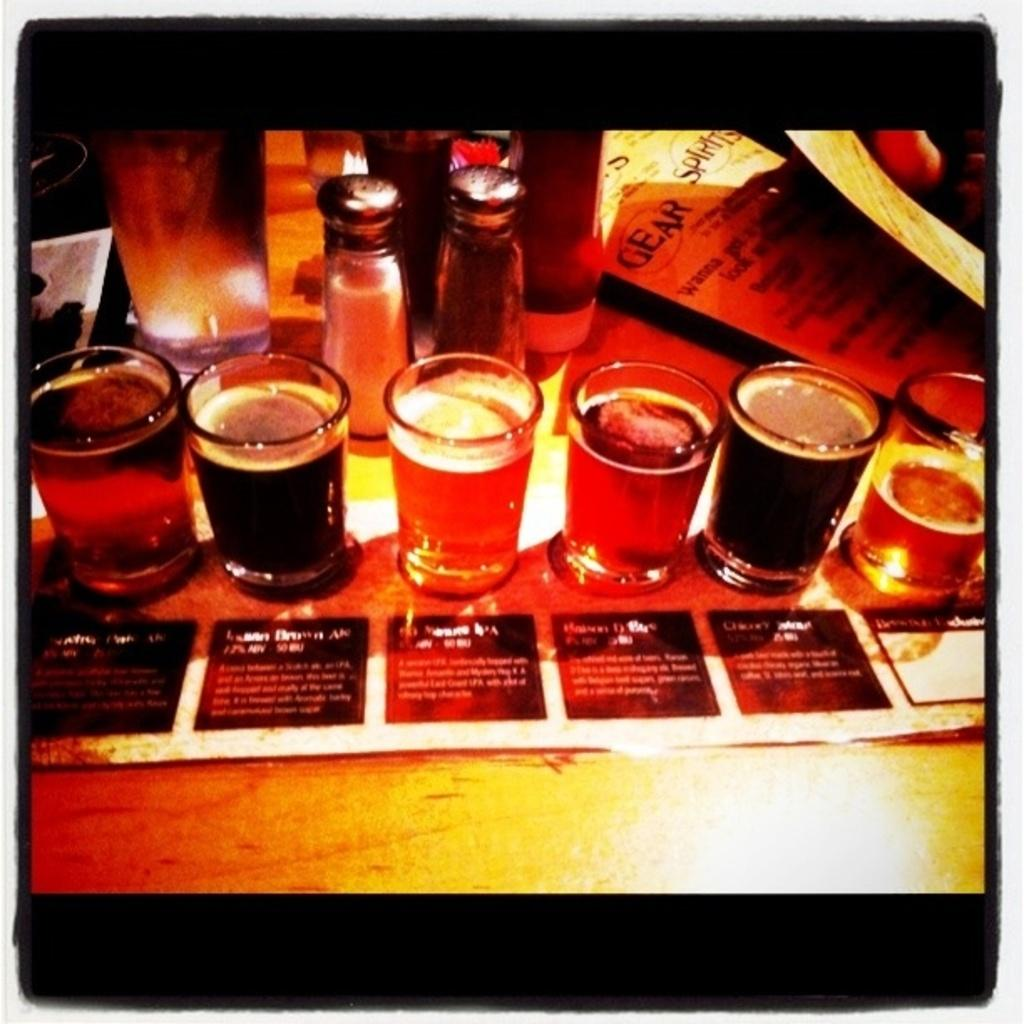What is in the glasses that are visible in the image? There are glasses filled with drink in the image. Where are the glasses placed in the image? The glasses are on a wooden plank. What else can be seen on the wooden plank besides the glasses? There are papers and jars on the wooden plank. How does the airplane stop on the wooden plank in the image? There is no airplane present in the image, so it cannot stop on the wooden plank. 